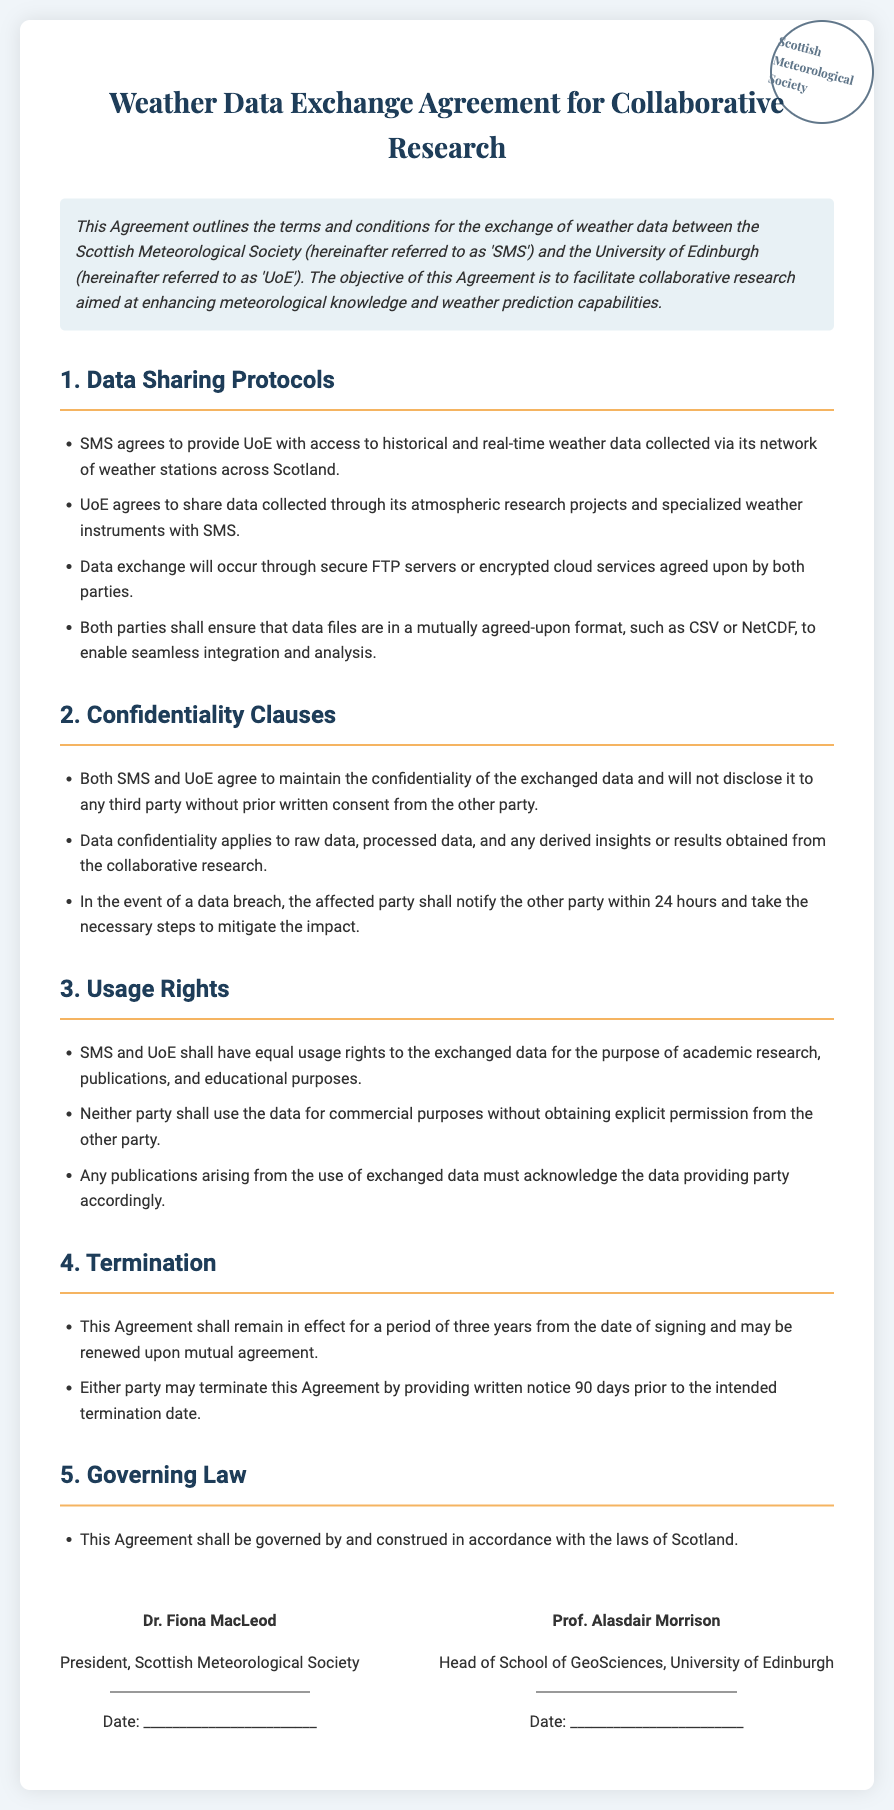what is the title of the agreement? The title of the agreement is the first heading in the document.
Answer: Weather Data Exchange Agreement for Collaborative Research who are the two parties involved in the agreement? The parties involved in the agreement are mentioned in the preamble.
Answer: Scottish Meteorological Society and University of Edinburgh how many years is the agreement effective? The duration of the agreement is specified in the termination section.
Answer: three years who is the president of the Scottish Meteorological Society? The document states the name and title of the signatory for SMS.
Answer: Dr. Fiona MacLeod what must both parties do in the event of a data breach? The document specifies the actions to be taken in case of a data breach.
Answer: notify the other party within 24 hours can either party use the data for commercial purposes? The usage rights section addresses the conditions for using the data.
Answer: no which governing law applies to the agreement? The governing law is mentioned towards the end of the document.
Answer: laws of Scotland what type of data will SMS provide to UoE? The type of data provided by SMS is detailed in the data sharing protocols.
Answer: historical and real-time weather data how should publications arising from the use of exchanged data acknowledge the data provider? The usage rights section outlines how to acknowledge the data provider in publications.
Answer: must acknowledge the data providing party accordingly 